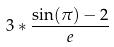<formula> <loc_0><loc_0><loc_500><loc_500>3 * \frac { \sin ( \pi ) - 2 } { e }</formula> 